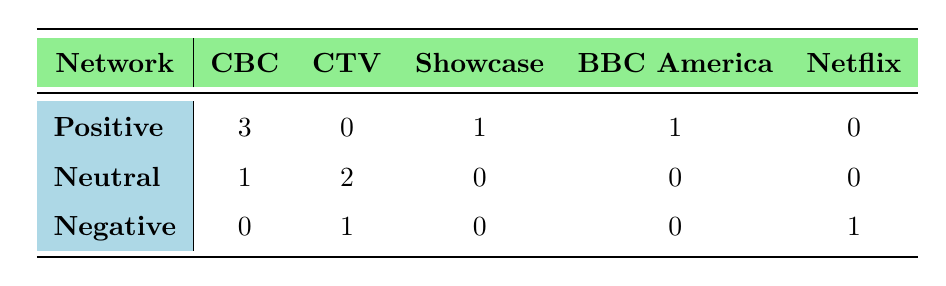What is the total number of positive critical receptions for shows on CBC? To find the total number of positive critical receptions for shows on CBC, we look at the CBC column under the Positive row. The value is 3, indicating that there are three shows with a positive reception on this network.
Answer: 3 Which network has the highest number of negative critical receptions? By examining the Negative row of each network, CBC has 0, CTV has 1, Showcase has 0, BBC America has 0, and Netflix has 1. Both CTV and Netflix are tied with the highest number of negative receptions, both having 1.
Answer: CTV and Netflix How many more positive than negative receptions are there for shows on CTV? For CTV, there are 0 positive and 1 negative reception. The difference is calculated as 0 (positive) - 1 (negative) = -1, indicating there are more negative than positive receptions.
Answer: -1 Is there any show on Showcase that has a neutral critical reception? Looking at the Showcase column in the Neutral row, the value is 0. This means there are no shows on Showcase that have a neutral critical reception.
Answer: No In total, how many neutral receptions are recorded across all networks? To find the total number of neutral receptions, we add up the values from the Neutral row: 1 (CBC) + 2 (CTV) + 0 (Showcase) + 0 (BBC America) + 0 (Netflix) = 3. Thus, there are three neutral receptions across all networks.
Answer: 3 Which network has the highest overall critical reception count for positive shows? The counts for positive receptions are: 3 for CBC, 0 for CTV, 1 for Showcase, 1 for BBC America, and 0 for Netflix. CBC has the highest count with 3 positive receptions.
Answer: CBC What percentage of the total shows examined received a positive critical reception? The total shows accounted in the table is 10. The positive receptions amount to 5 (3 CBC + 1 Showcase + 1 BBC America). Thus, the percentage is (5/10) * 100 = 50%.
Answer: 50% Are there more shows with neutral or positive critical receptions in total? Total counts show 5 positive (3 CBC + 1 Showcase + 1 BBC America) and 3 neutral (1 CBC + 2 CTV). Since 5 (positive) is greater than 3 (neutral), there are more shows with positive critical receptions.
Answer: Yes 